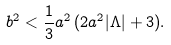Convert formula to latex. <formula><loc_0><loc_0><loc_500><loc_500>b ^ { 2 } < \frac { 1 } { 3 } a ^ { 2 } \, ( 2 a ^ { 2 } | \Lambda | + 3 ) .</formula> 